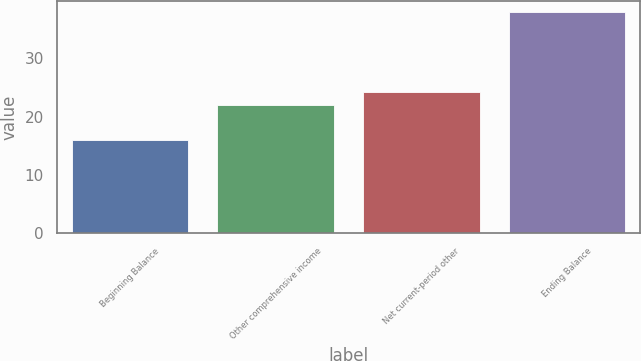<chart> <loc_0><loc_0><loc_500><loc_500><bar_chart><fcel>Beginning Balance<fcel>Other comprehensive income<fcel>Net current-period other<fcel>Ending Balance<nl><fcel>16<fcel>22<fcel>24.2<fcel>38<nl></chart> 